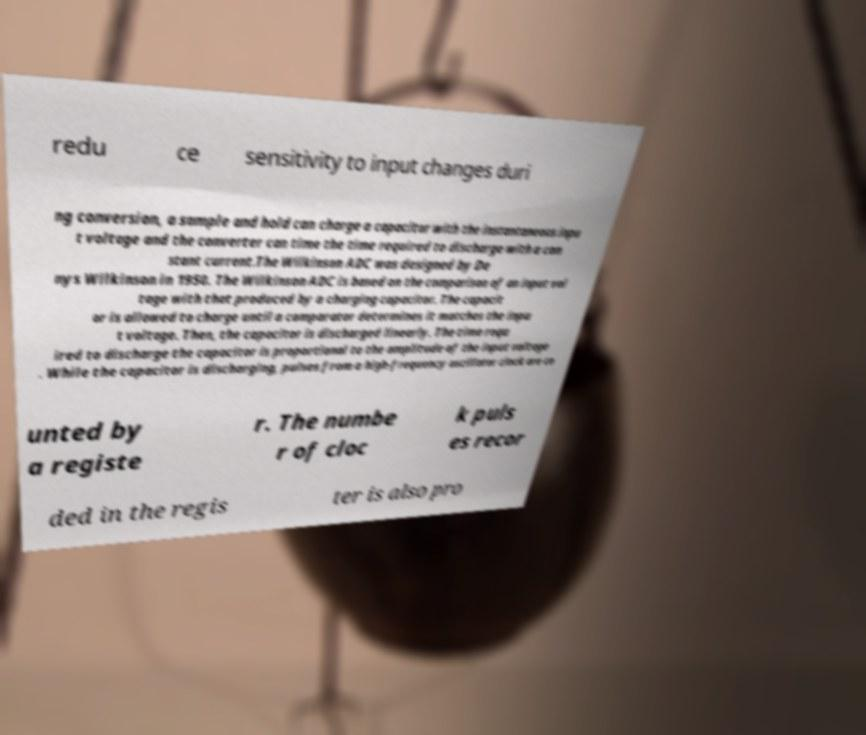Please identify and transcribe the text found in this image. redu ce sensitivity to input changes duri ng conversion, a sample and hold can charge a capacitor with the instantaneous inpu t voltage and the converter can time the time required to discharge with a con stant current.The Wilkinson ADC was designed by De nys Wilkinson in 1950. The Wilkinson ADC is based on the comparison of an input vol tage with that produced by a charging capacitor. The capacit or is allowed to charge until a comparator determines it matches the inpu t voltage. Then, the capacitor is discharged linearly. The time requ ired to discharge the capacitor is proportional to the amplitude of the input voltage . While the capacitor is discharging, pulses from a high-frequency oscillator clock are co unted by a registe r. The numbe r of cloc k puls es recor ded in the regis ter is also pro 